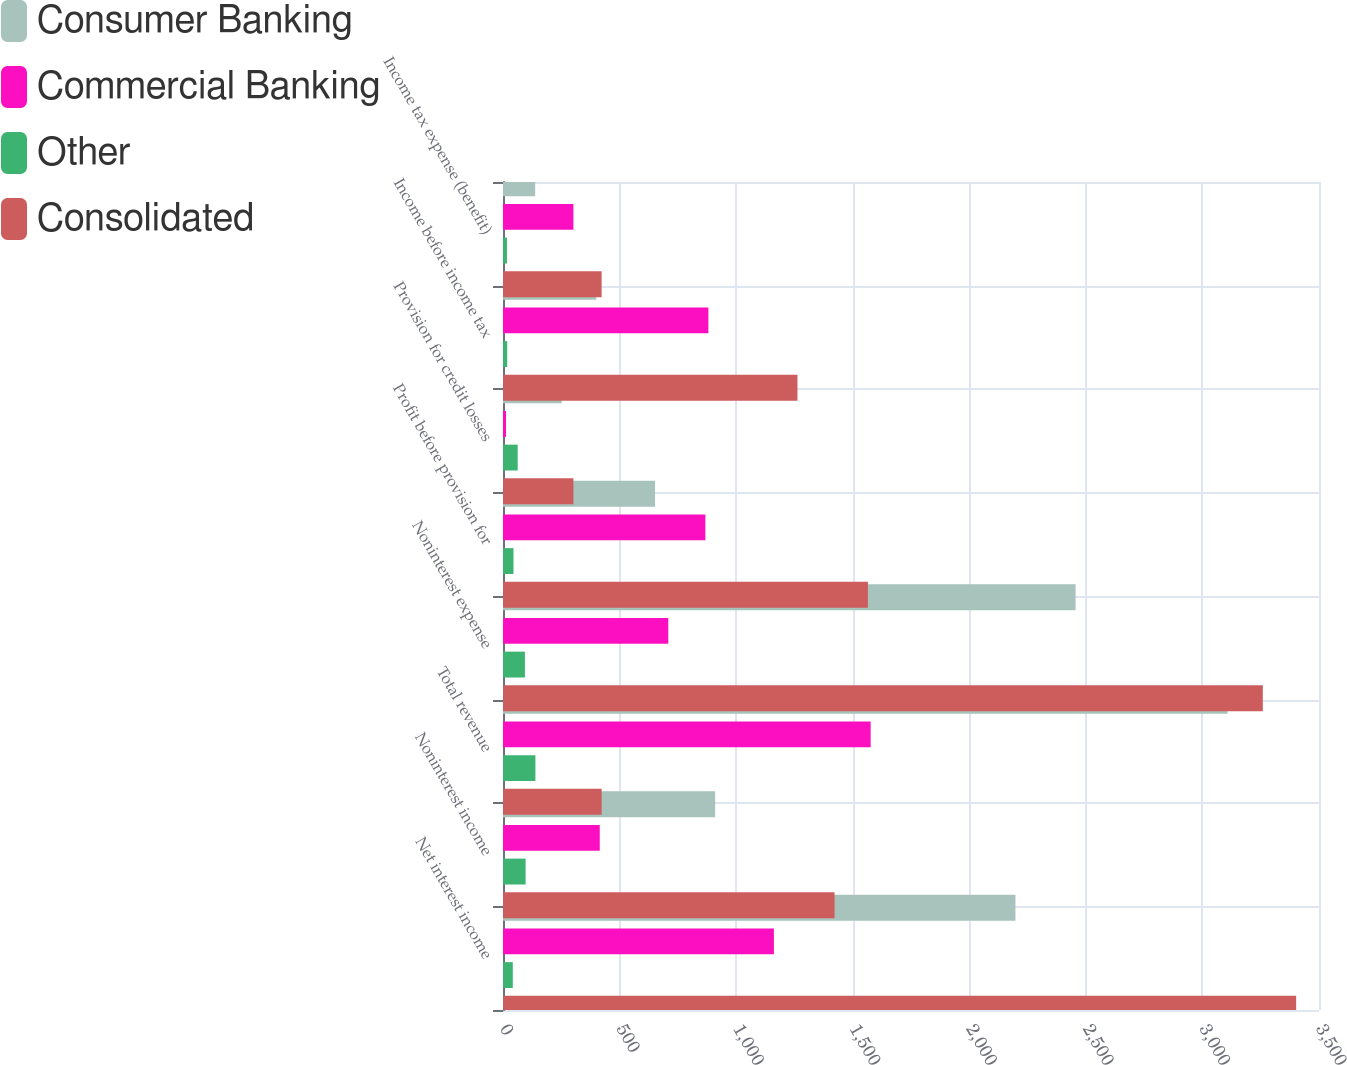Convert chart. <chart><loc_0><loc_0><loc_500><loc_500><stacked_bar_chart><ecel><fcel>Net interest income<fcel>Noninterest income<fcel>Total revenue<fcel>Noninterest expense<fcel>Profit before provision for<fcel>Provision for credit losses<fcel>Income before income tax<fcel>Income tax expense (benefit)<nl><fcel>Consumer Banking<fcel>2198<fcel>910<fcel>3108<fcel>2456<fcel>652<fcel>252<fcel>400<fcel>138<nl><fcel>Commercial Banking<fcel>1162<fcel>415<fcel>1577<fcel>709<fcel>868<fcel>13<fcel>881<fcel>302<nl><fcel>Other<fcel>42<fcel>97<fcel>139<fcel>94<fcel>45<fcel>63<fcel>18<fcel>17<nl><fcel>Consolidated<fcel>3402<fcel>1422<fcel>423<fcel>3259<fcel>1565<fcel>302<fcel>1263<fcel>423<nl></chart> 